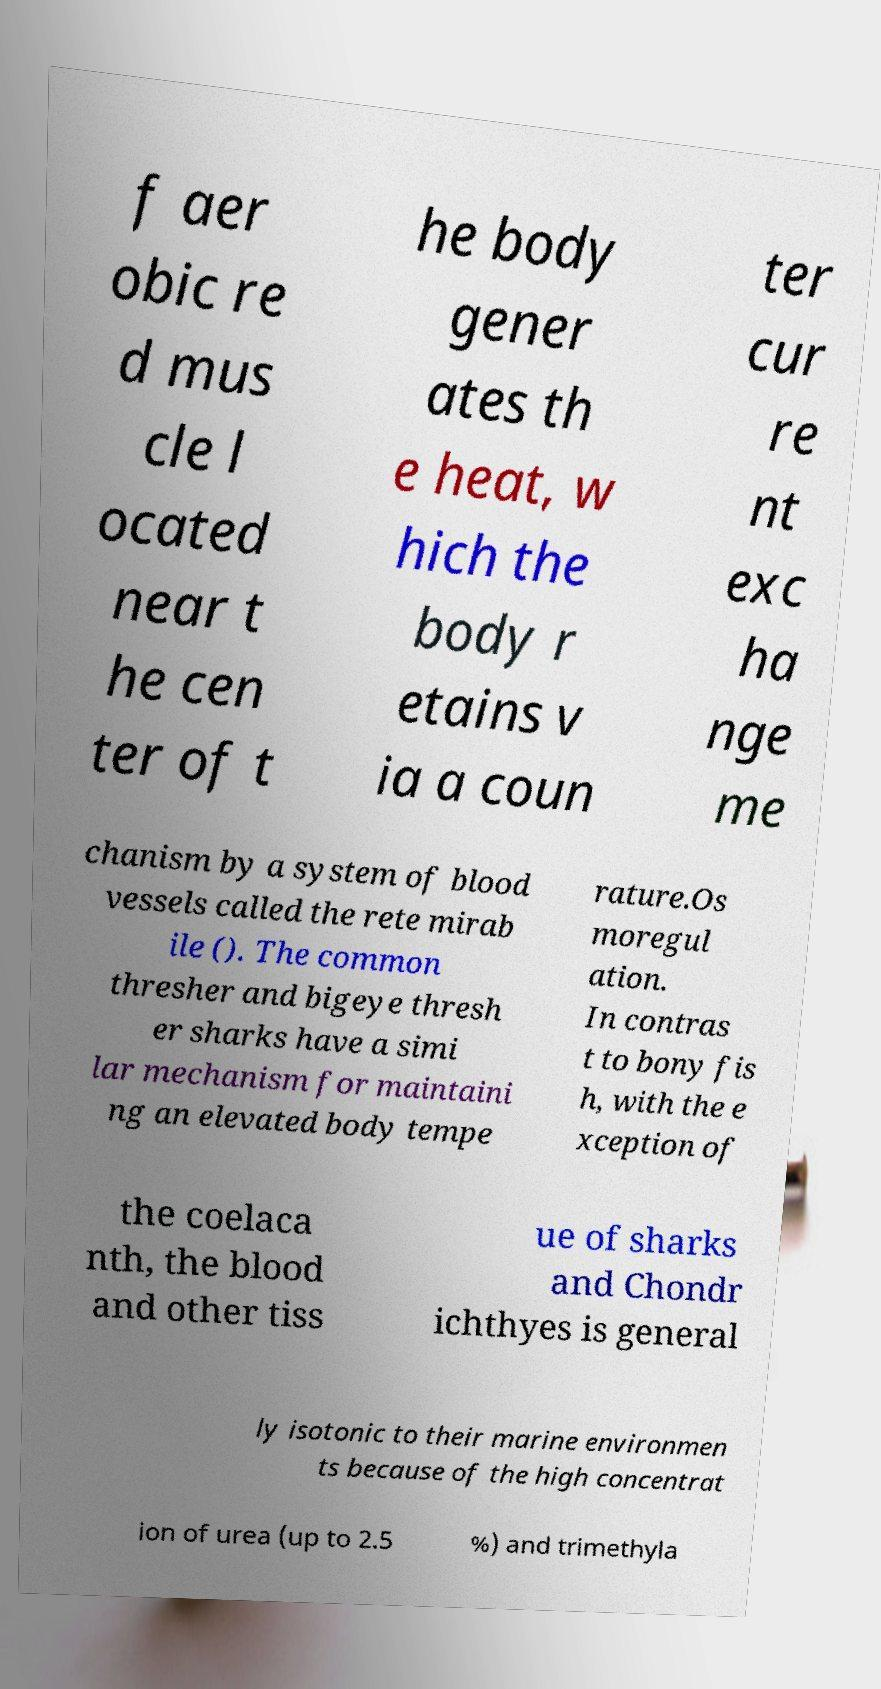Can you accurately transcribe the text from the provided image for me? f aer obic re d mus cle l ocated near t he cen ter of t he body gener ates th e heat, w hich the body r etains v ia a coun ter cur re nt exc ha nge me chanism by a system of blood vessels called the rete mirab ile (). The common thresher and bigeye thresh er sharks have a simi lar mechanism for maintaini ng an elevated body tempe rature.Os moregul ation. In contras t to bony fis h, with the e xception of the coelaca nth, the blood and other tiss ue of sharks and Chondr ichthyes is general ly isotonic to their marine environmen ts because of the high concentrat ion of urea (up to 2.5 %) and trimethyla 